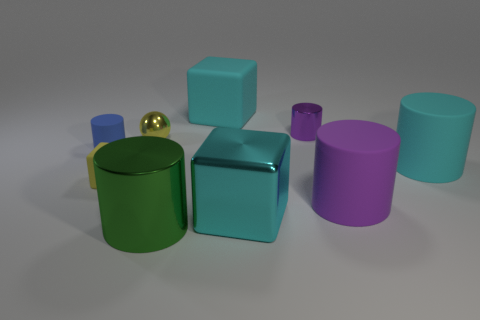There is a small object that is the same color as the small matte cube; what material is it?
Offer a very short reply. Metal. What number of things are in front of the big cyan shiny cube and left of the yellow cube?
Make the answer very short. 0. What is the shape of the tiny thing to the right of the large shiny block?
Ensure brevity in your answer.  Cylinder. Is the number of blue cylinders that are in front of the big metal block less than the number of cyan metallic cubes that are behind the tiny purple cylinder?
Offer a terse response. No. Does the big cyan cube that is behind the big purple rubber cylinder have the same material as the large block that is in front of the big purple cylinder?
Give a very brief answer. No. The small yellow metallic object is what shape?
Ensure brevity in your answer.  Sphere. Are there more large cyan rubber things in front of the tiny yellow sphere than big cyan cubes in front of the cyan shiny block?
Keep it short and to the point. Yes. Is the shape of the large cyan object behind the cyan cylinder the same as the small object that is to the right of the big metallic cylinder?
Your answer should be very brief. No. How many other objects are the same size as the cyan cylinder?
Provide a short and direct response. 4. The cyan metallic cube is what size?
Provide a succinct answer. Large. 